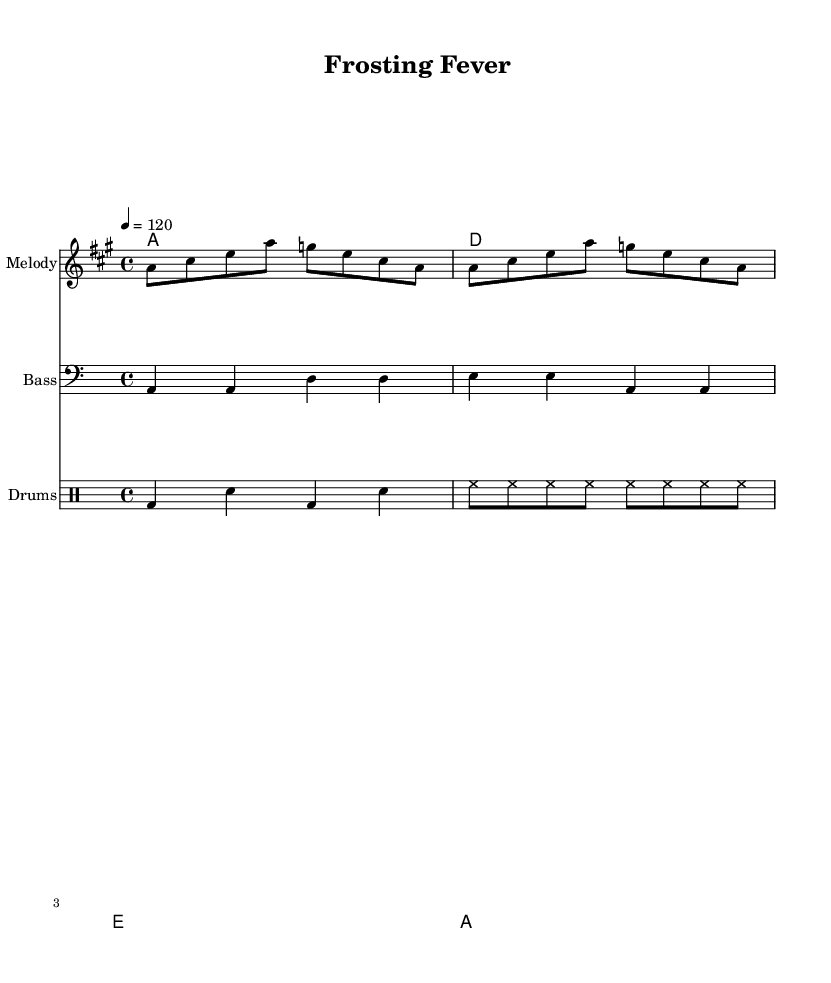What is the key signature of this music? The key signature is A major, which has three sharps: F sharp, C sharp, and G sharp. This can be seen at the beginning of the staff where the sharps are indicated.
Answer: A major What is the time signature of this piece? The time signature is 4/4, which means there are four beats in each measure and the quarter note receives one beat. This is indicated at the beginning of the score next to the key signature.
Answer: 4/4 What is the tempo marking for this music? The tempo marking is quarter note equals 120. This indicates the speed of the piece, with the quarter note played at 120 beats per minute, as shown at the top of the score.
Answer: 120 How many measures are in the melody section? The melody section has 4 measures. This can be determined by counting the vertical bar lines that separate the measures in the melody staff.
Answer: 4 Which chords are used in this piece? The chords used in this piece are A, D, and E. This can be deduced from the chord names indicated in the chord names staff, showing the progression.
Answer: A, D, E What is the role of the bassline in this disco song? The bassline provides rhythmic support and harmonic foundation, played in a lower register, typically enhancing the groove and pulse of the disco feel. This can be understood by observing the bass clef and the notes along with their rhythm.
Answer: Rhythmic support How is the drum part formatted in this score? The drum part is formatted in a separate staff using drum notation, showing specific rhythms represented through bass drum (bd), snare (sn), and hi-hat (hh) symbols. This can be noted by recognizing the different clef used and the notation system for drums.
Answer: Separate staff 